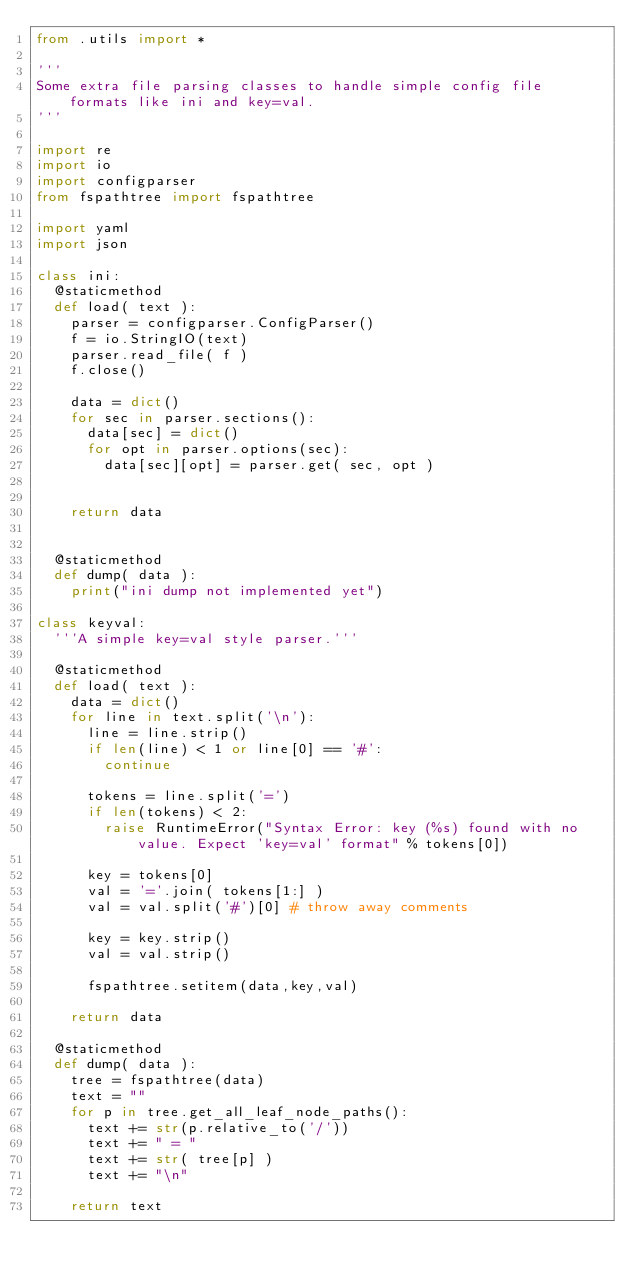<code> <loc_0><loc_0><loc_500><loc_500><_Python_>from .utils import *

'''
Some extra file parsing classes to handle simple config file formats like ini and key=val.
'''

import re
import io
import configparser
from fspathtree import fspathtree

import yaml
import json

class ini:
  @staticmethod
  def load( text ):
    parser = configparser.ConfigParser()
    f = io.StringIO(text)
    parser.read_file( f )
    f.close()

    data = dict()
    for sec in parser.sections():
      data[sec] = dict()
      for opt in parser.options(sec):
        data[sec][opt] = parser.get( sec, opt )

      
    return data


  @staticmethod
  def dump( data ):
    print("ini dump not implemented yet")

class keyval:
  '''A simple key=val style parser.'''

  @staticmethod
  def load( text ):
    data = dict()
    for line in text.split('\n'):
      line = line.strip()
      if len(line) < 1 or line[0] == '#':
        continue

      tokens = line.split('=')
      if len(tokens) < 2:
        raise RuntimeError("Syntax Error: key (%s) found with no value. Expect 'key=val' format" % tokens[0])

      key = tokens[0]
      val = '='.join( tokens[1:] )
      val = val.split('#')[0] # throw away comments

      key = key.strip()
      val = val.strip()

      fspathtree.setitem(data,key,val)

    return data

  @staticmethod
  def dump( data ):
    tree = fspathtree(data)
    text = ""
    for p in tree.get_all_leaf_node_paths():
      text += str(p.relative_to('/'))
      text += " = "
      text += str( tree[p] )
      text += "\n"

    return text
</code> 